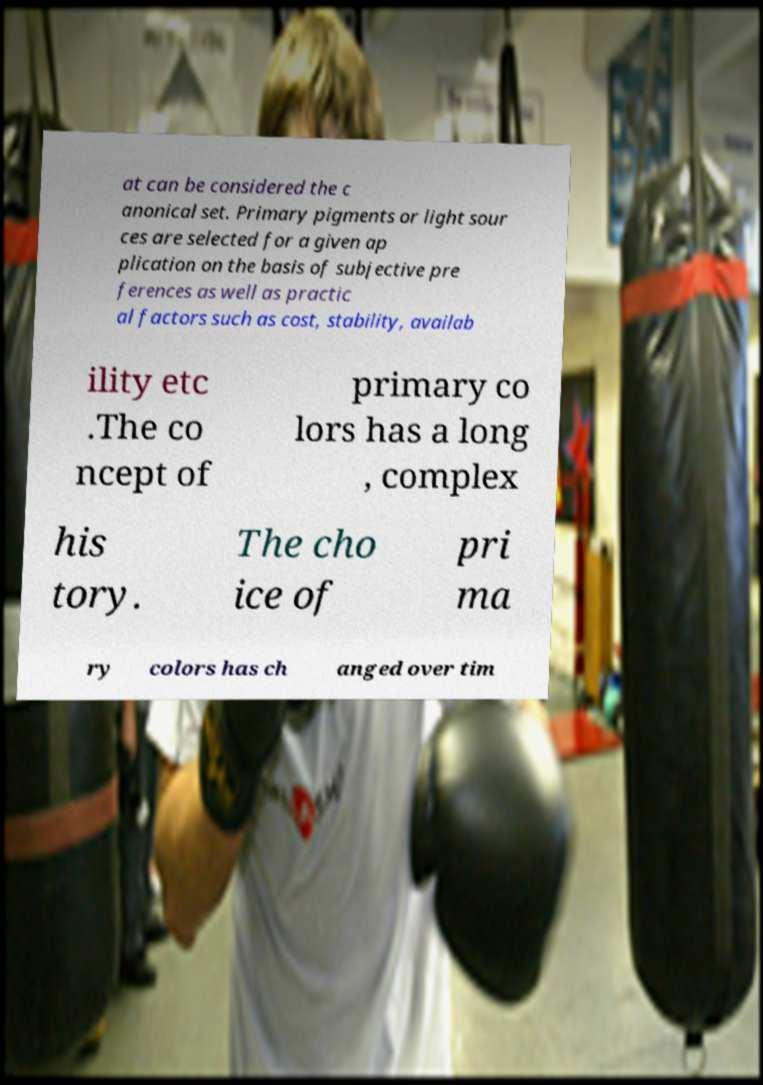Please read and relay the text visible in this image. What does it say? at can be considered the c anonical set. Primary pigments or light sour ces are selected for a given ap plication on the basis of subjective pre ferences as well as practic al factors such as cost, stability, availab ility etc .The co ncept of primary co lors has a long , complex his tory. The cho ice of pri ma ry colors has ch anged over tim 